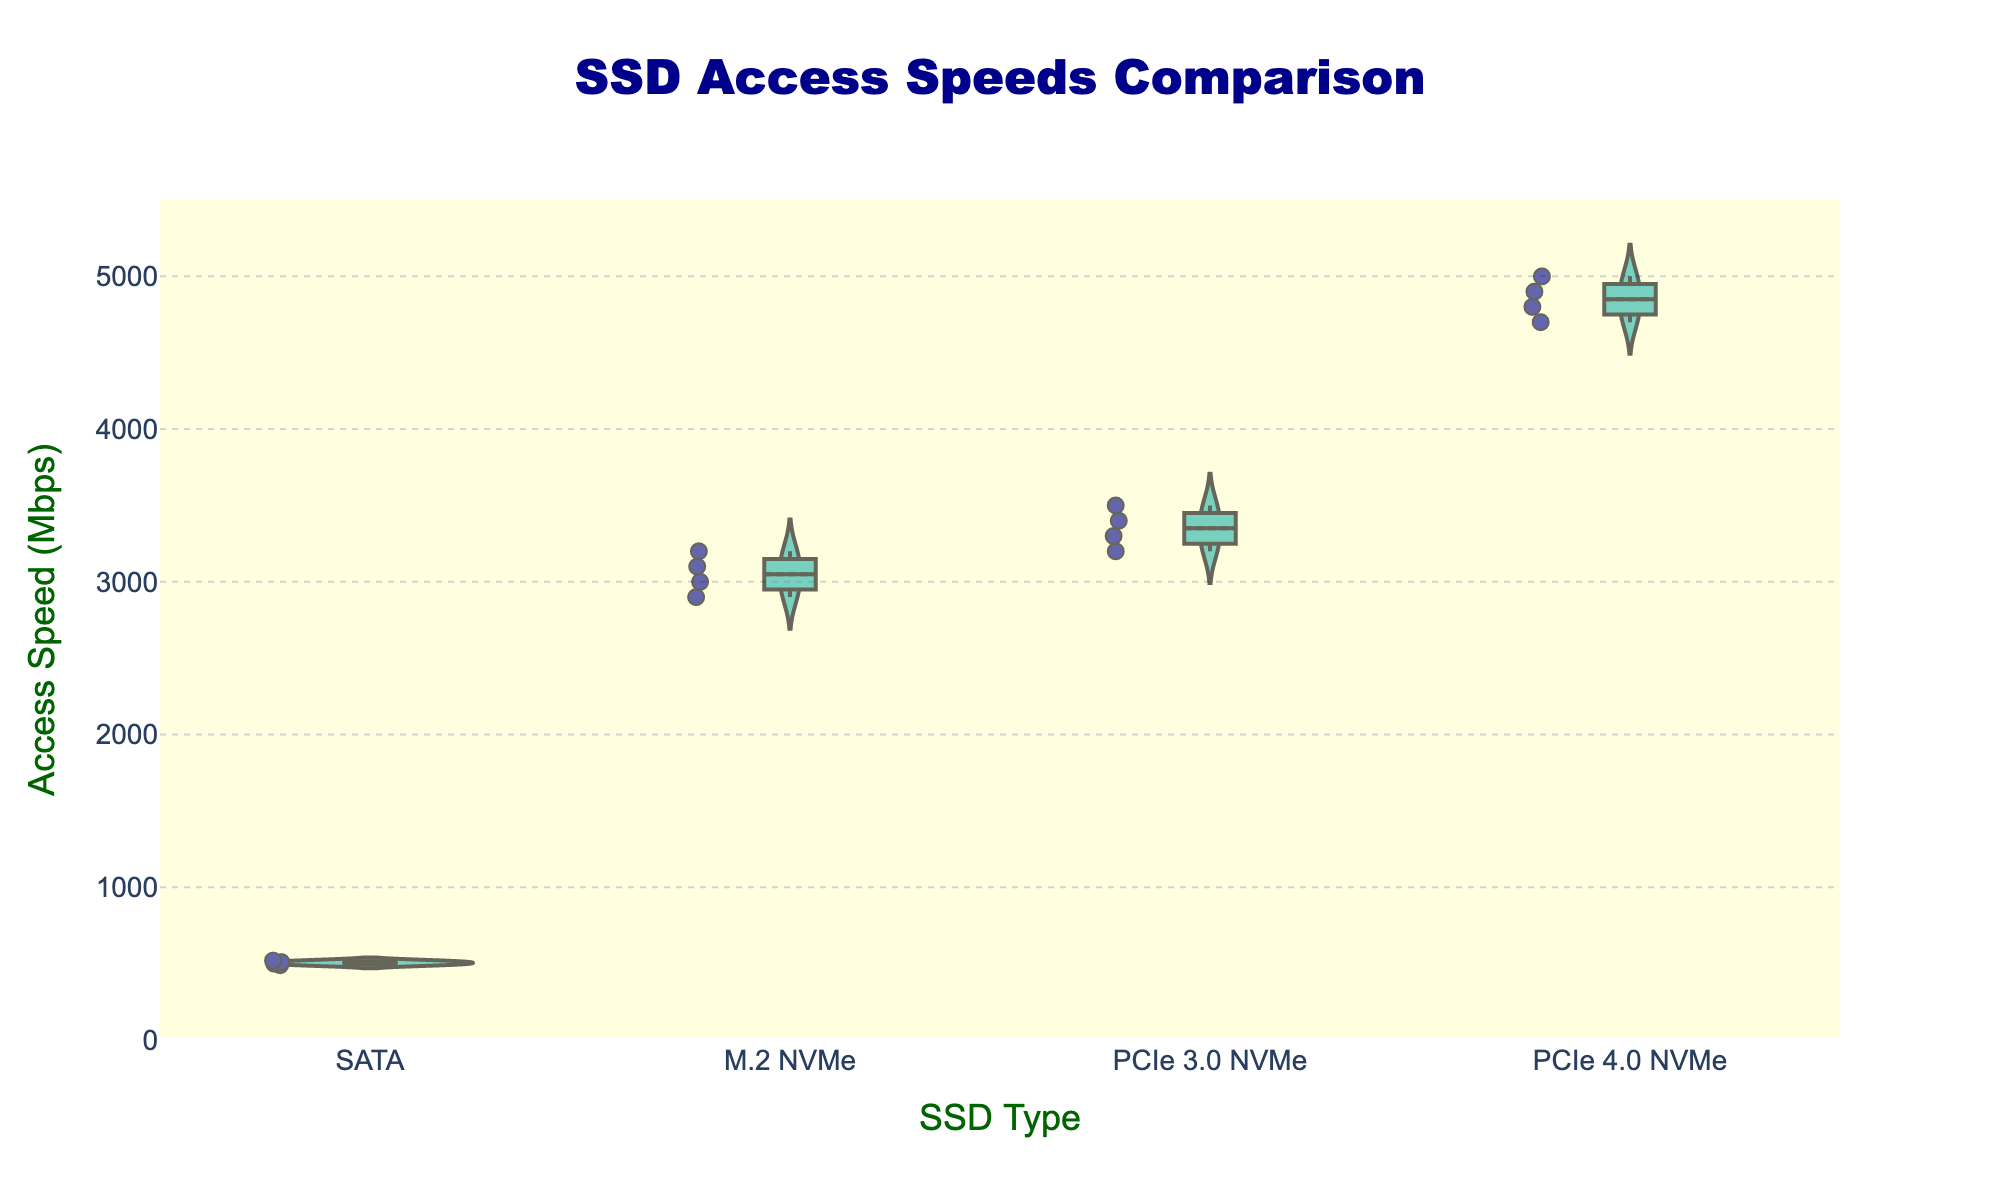How many types of SSDs are compared in the figure? The x-axis of the figure lists the different types of SSDs. By counting the distinct categories, we can find the number of SSD types compared.
Answer: 4 What is the title of the figure? The title of the figure is prominently displayed at the top center.
Answer: SSD Access Speeds Comparison Which type of SSD has the highest recorded access speed? By observing the highest points of the violin plots and box plots overlaid, we can see which SSD type reaches the maximum value on the y-axis.
Answer: PCIe 4.0 NVMe What is the median access speed of SATA SSDs? The median value is indicated by the thick horizontal line within the box in the box plot for the SATA category.
Answer: 505 Mbps Which type of SSD shows the most variability in access speed? Variability can be assessed by the spread of the violin plot and the range of the box plot. The type with the widest distribution demonstrates the most variability.
Answer: PCIe 4.0 NVMe What is the interquartile range (IQR) of access speeds for M.2 NVMe SSDs? The IQR can be determined by finding the difference between the upper quartile (75th percentile) and the lower quartile (25th percentile) values in the box plot for M.2 NVMe SSDs. The box plot shows these quartiles as the top and bottom edges of the box.
Answer: 300 Mbps Compare the median access speeds between PCIe 3.0 NVMe and PCIe 4.0 NVMe. How much faster is PCIe 4.0 NVMe on average? The medians are shown by horizontal lines in the boxes for each type. The difference in these median values indicates how much faster PCIe 4.0 NVMe is compared to PCIe 3.0 NVMe.
Answer: 1500 Mbps Is there any overlap in access speeds between SATA and M.2 NVMe SSDs? Overlap can be observed by comparing the range of access speeds represented by the violin plots and box plots of SATA and M.2 NVMe SSDs. Overlapping ranges would suggest shared speeds.
Answer: No How are individual data points represented in the figure? Individual data points in the figure can be identified by specific markers or dots superimposed on the violin and box plots.
Answer: Dots What does the shaded area in each violin plot represent? The shaded area in each violin plot represents the density of data points at different access speed values, giving an impression of the distribution's shape.
Answer: Density distribution 